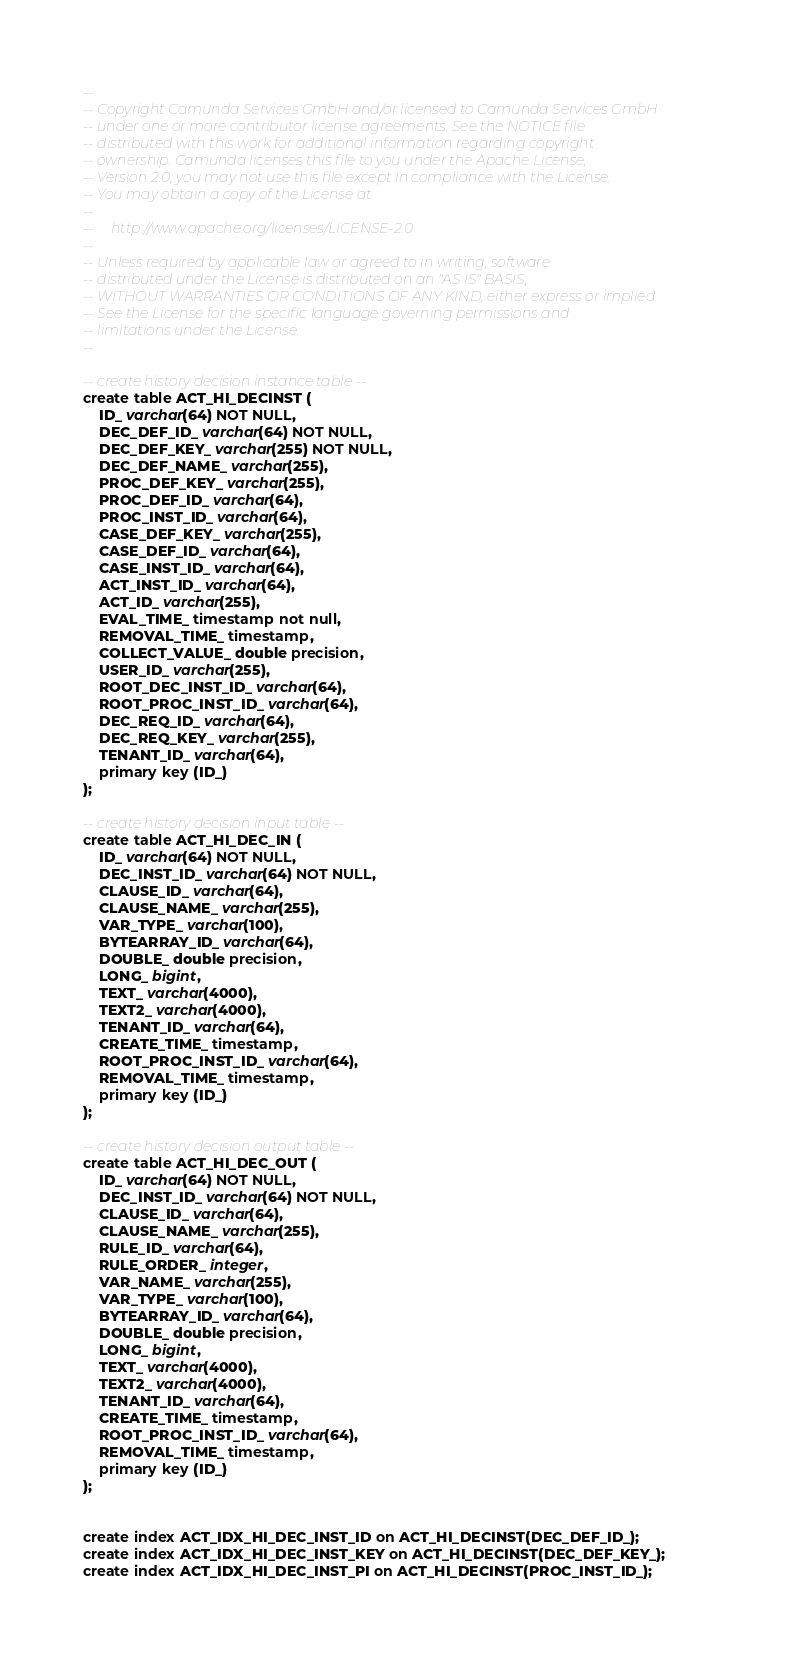<code> <loc_0><loc_0><loc_500><loc_500><_SQL_>--
-- Copyright Camunda Services GmbH and/or licensed to Camunda Services GmbH
-- under one or more contributor license agreements. See the NOTICE file
-- distributed with this work for additional information regarding copyright
-- ownership. Camunda licenses this file to you under the Apache License,
-- Version 2.0; you may not use this file except in compliance with the License.
-- You may obtain a copy of the License at
--
--     http://www.apache.org/licenses/LICENSE-2.0
--
-- Unless required by applicable law or agreed to in writing, software
-- distributed under the License is distributed on an "AS IS" BASIS,
-- WITHOUT WARRANTIES OR CONDITIONS OF ANY KIND, either express or implied.
-- See the License for the specific language governing permissions and
-- limitations under the License.
--

-- create history decision instance table --
create table ACT_HI_DECINST (
    ID_ varchar(64) NOT NULL,
    DEC_DEF_ID_ varchar(64) NOT NULL,
    DEC_DEF_KEY_ varchar(255) NOT NULL,
    DEC_DEF_NAME_ varchar(255),
    PROC_DEF_KEY_ varchar(255),
    PROC_DEF_ID_ varchar(64),
    PROC_INST_ID_ varchar(64),
    CASE_DEF_KEY_ varchar(255),
    CASE_DEF_ID_ varchar(64),
    CASE_INST_ID_ varchar(64),
    ACT_INST_ID_ varchar(64),
    ACT_ID_ varchar(255),
    EVAL_TIME_ timestamp not null,
    REMOVAL_TIME_ timestamp,
    COLLECT_VALUE_ double precision,
    USER_ID_ varchar(255),
    ROOT_DEC_INST_ID_ varchar(64),
    ROOT_PROC_INST_ID_ varchar(64),
    DEC_REQ_ID_ varchar(64),
    DEC_REQ_KEY_ varchar(255),
    TENANT_ID_ varchar(64),
    primary key (ID_)
);

-- create history decision input table --
create table ACT_HI_DEC_IN (
    ID_ varchar(64) NOT NULL,
    DEC_INST_ID_ varchar(64) NOT NULL,
    CLAUSE_ID_ varchar(64),
    CLAUSE_NAME_ varchar(255),
    VAR_TYPE_ varchar(100),
    BYTEARRAY_ID_ varchar(64),
    DOUBLE_ double precision,
    LONG_ bigint,
    TEXT_ varchar(4000),
    TEXT2_ varchar(4000),
    TENANT_ID_ varchar(64),
    CREATE_TIME_ timestamp,
    ROOT_PROC_INST_ID_ varchar(64),
    REMOVAL_TIME_ timestamp,
    primary key (ID_)
);

-- create history decision output table --
create table ACT_HI_DEC_OUT (
    ID_ varchar(64) NOT NULL,
    DEC_INST_ID_ varchar(64) NOT NULL,
    CLAUSE_ID_ varchar(64),
    CLAUSE_NAME_ varchar(255),
    RULE_ID_ varchar(64),
    RULE_ORDER_ integer,
    VAR_NAME_ varchar(255),
    VAR_TYPE_ varchar(100),
    BYTEARRAY_ID_ varchar(64),
    DOUBLE_ double precision,
    LONG_ bigint,
    TEXT_ varchar(4000),
    TEXT2_ varchar(4000),
    TENANT_ID_ varchar(64),
    CREATE_TIME_ timestamp,
    ROOT_PROC_INST_ID_ varchar(64),
    REMOVAL_TIME_ timestamp,
    primary key (ID_)
);


create index ACT_IDX_HI_DEC_INST_ID on ACT_HI_DECINST(DEC_DEF_ID_);
create index ACT_IDX_HI_DEC_INST_KEY on ACT_HI_DECINST(DEC_DEF_KEY_);
create index ACT_IDX_HI_DEC_INST_PI on ACT_HI_DECINST(PROC_INST_ID_);</code> 